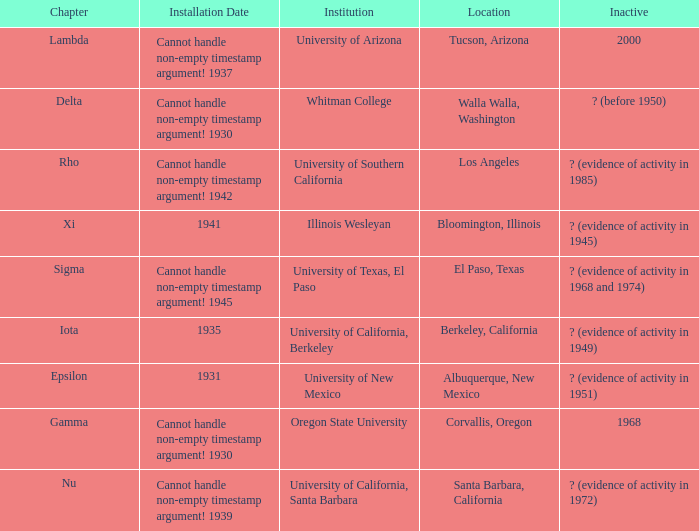What does the inactive state for University of Texas, El Paso?  ? (evidence of activity in 1968 and 1974). 